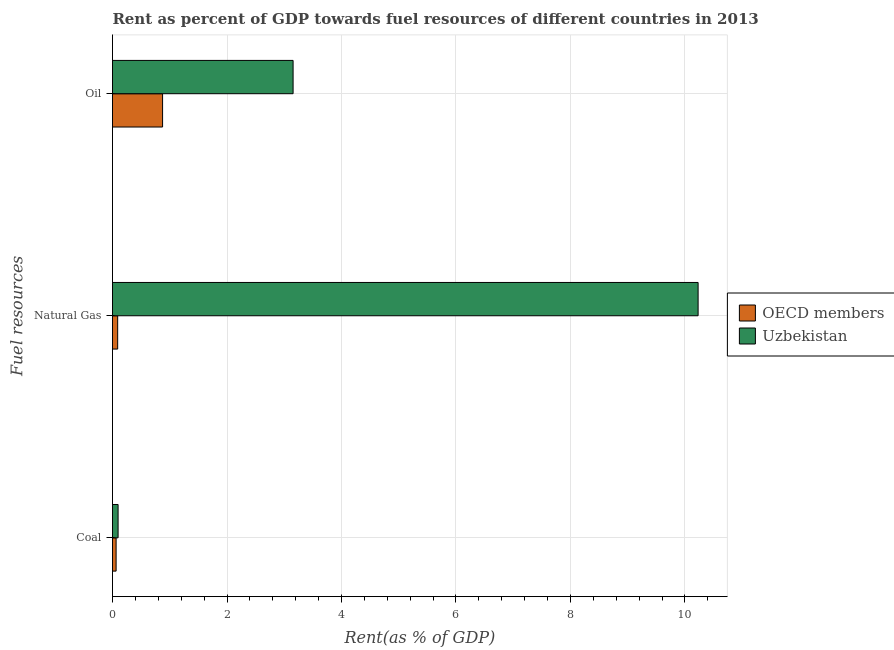How many different coloured bars are there?
Keep it short and to the point. 2. Are the number of bars per tick equal to the number of legend labels?
Offer a terse response. Yes. How many bars are there on the 2nd tick from the bottom?
Ensure brevity in your answer.  2. What is the label of the 1st group of bars from the top?
Ensure brevity in your answer.  Oil. What is the rent towards natural gas in OECD members?
Provide a succinct answer. 0.09. Across all countries, what is the maximum rent towards coal?
Provide a short and direct response. 0.1. Across all countries, what is the minimum rent towards coal?
Your answer should be compact. 0.06. In which country was the rent towards coal maximum?
Offer a very short reply. Uzbekistan. In which country was the rent towards coal minimum?
Provide a short and direct response. OECD members. What is the total rent towards coal in the graph?
Give a very brief answer. 0.16. What is the difference between the rent towards oil in OECD members and that in Uzbekistan?
Give a very brief answer. -2.28. What is the difference between the rent towards coal in OECD members and the rent towards natural gas in Uzbekistan?
Offer a terse response. -10.17. What is the average rent towards oil per country?
Your answer should be compact. 2.01. What is the difference between the rent towards natural gas and rent towards oil in Uzbekistan?
Ensure brevity in your answer.  7.08. In how many countries, is the rent towards natural gas greater than 4.8 %?
Your response must be concise. 1. What is the ratio of the rent towards natural gas in Uzbekistan to that in OECD members?
Your response must be concise. 113.43. Is the rent towards coal in OECD members less than that in Uzbekistan?
Provide a short and direct response. Yes. Is the difference between the rent towards oil in Uzbekistan and OECD members greater than the difference between the rent towards coal in Uzbekistan and OECD members?
Your answer should be very brief. Yes. What is the difference between the highest and the second highest rent towards natural gas?
Offer a terse response. 10.14. What is the difference between the highest and the lowest rent towards natural gas?
Give a very brief answer. 10.14. What does the 2nd bar from the top in Oil represents?
Offer a very short reply. OECD members. What does the 2nd bar from the bottom in Oil represents?
Keep it short and to the point. Uzbekistan. How many bars are there?
Your answer should be compact. 6. Are all the bars in the graph horizontal?
Provide a succinct answer. Yes. How many countries are there in the graph?
Provide a succinct answer. 2. Where does the legend appear in the graph?
Your answer should be very brief. Center right. How are the legend labels stacked?
Provide a succinct answer. Vertical. What is the title of the graph?
Ensure brevity in your answer.  Rent as percent of GDP towards fuel resources of different countries in 2013. Does "Swaziland" appear as one of the legend labels in the graph?
Offer a terse response. No. What is the label or title of the X-axis?
Offer a very short reply. Rent(as % of GDP). What is the label or title of the Y-axis?
Give a very brief answer. Fuel resources. What is the Rent(as % of GDP) of OECD members in Coal?
Give a very brief answer. 0.06. What is the Rent(as % of GDP) in Uzbekistan in Coal?
Provide a succinct answer. 0.1. What is the Rent(as % of GDP) of OECD members in Natural Gas?
Your response must be concise. 0.09. What is the Rent(as % of GDP) in Uzbekistan in Natural Gas?
Your answer should be compact. 10.23. What is the Rent(as % of GDP) of OECD members in Oil?
Keep it short and to the point. 0.87. What is the Rent(as % of GDP) in Uzbekistan in Oil?
Give a very brief answer. 3.15. Across all Fuel resources, what is the maximum Rent(as % of GDP) of OECD members?
Your answer should be compact. 0.87. Across all Fuel resources, what is the maximum Rent(as % of GDP) of Uzbekistan?
Offer a terse response. 10.23. Across all Fuel resources, what is the minimum Rent(as % of GDP) of OECD members?
Your response must be concise. 0.06. Across all Fuel resources, what is the minimum Rent(as % of GDP) of Uzbekistan?
Provide a succinct answer. 0.1. What is the total Rent(as % of GDP) in OECD members in the graph?
Ensure brevity in your answer.  1.03. What is the total Rent(as % of GDP) in Uzbekistan in the graph?
Provide a short and direct response. 13.48. What is the difference between the Rent(as % of GDP) in OECD members in Coal and that in Natural Gas?
Offer a very short reply. -0.03. What is the difference between the Rent(as % of GDP) in Uzbekistan in Coal and that in Natural Gas?
Offer a terse response. -10.13. What is the difference between the Rent(as % of GDP) in OECD members in Coal and that in Oil?
Your answer should be very brief. -0.81. What is the difference between the Rent(as % of GDP) in Uzbekistan in Coal and that in Oil?
Offer a very short reply. -3.06. What is the difference between the Rent(as % of GDP) in OECD members in Natural Gas and that in Oil?
Ensure brevity in your answer.  -0.78. What is the difference between the Rent(as % of GDP) of Uzbekistan in Natural Gas and that in Oil?
Offer a very short reply. 7.08. What is the difference between the Rent(as % of GDP) of OECD members in Coal and the Rent(as % of GDP) of Uzbekistan in Natural Gas?
Provide a short and direct response. -10.17. What is the difference between the Rent(as % of GDP) in OECD members in Coal and the Rent(as % of GDP) in Uzbekistan in Oil?
Ensure brevity in your answer.  -3.09. What is the difference between the Rent(as % of GDP) in OECD members in Natural Gas and the Rent(as % of GDP) in Uzbekistan in Oil?
Provide a succinct answer. -3.06. What is the average Rent(as % of GDP) in OECD members per Fuel resources?
Your answer should be compact. 0.34. What is the average Rent(as % of GDP) in Uzbekistan per Fuel resources?
Provide a short and direct response. 4.49. What is the difference between the Rent(as % of GDP) in OECD members and Rent(as % of GDP) in Uzbekistan in Coal?
Make the answer very short. -0.03. What is the difference between the Rent(as % of GDP) of OECD members and Rent(as % of GDP) of Uzbekistan in Natural Gas?
Ensure brevity in your answer.  -10.14. What is the difference between the Rent(as % of GDP) in OECD members and Rent(as % of GDP) in Uzbekistan in Oil?
Your answer should be very brief. -2.28. What is the ratio of the Rent(as % of GDP) of OECD members in Coal to that in Natural Gas?
Your response must be concise. 0.7. What is the ratio of the Rent(as % of GDP) in Uzbekistan in Coal to that in Natural Gas?
Provide a succinct answer. 0.01. What is the ratio of the Rent(as % of GDP) in OECD members in Coal to that in Oil?
Keep it short and to the point. 0.07. What is the ratio of the Rent(as % of GDP) in Uzbekistan in Coal to that in Oil?
Give a very brief answer. 0.03. What is the ratio of the Rent(as % of GDP) in OECD members in Natural Gas to that in Oil?
Ensure brevity in your answer.  0.1. What is the ratio of the Rent(as % of GDP) in Uzbekistan in Natural Gas to that in Oil?
Your response must be concise. 3.24. What is the difference between the highest and the second highest Rent(as % of GDP) in OECD members?
Provide a short and direct response. 0.78. What is the difference between the highest and the second highest Rent(as % of GDP) of Uzbekistan?
Give a very brief answer. 7.08. What is the difference between the highest and the lowest Rent(as % of GDP) of OECD members?
Your answer should be compact. 0.81. What is the difference between the highest and the lowest Rent(as % of GDP) of Uzbekistan?
Your response must be concise. 10.13. 